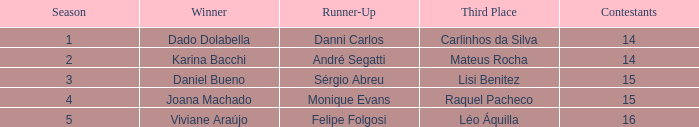In what season was the winner Dado Dolabella? 1.0. 